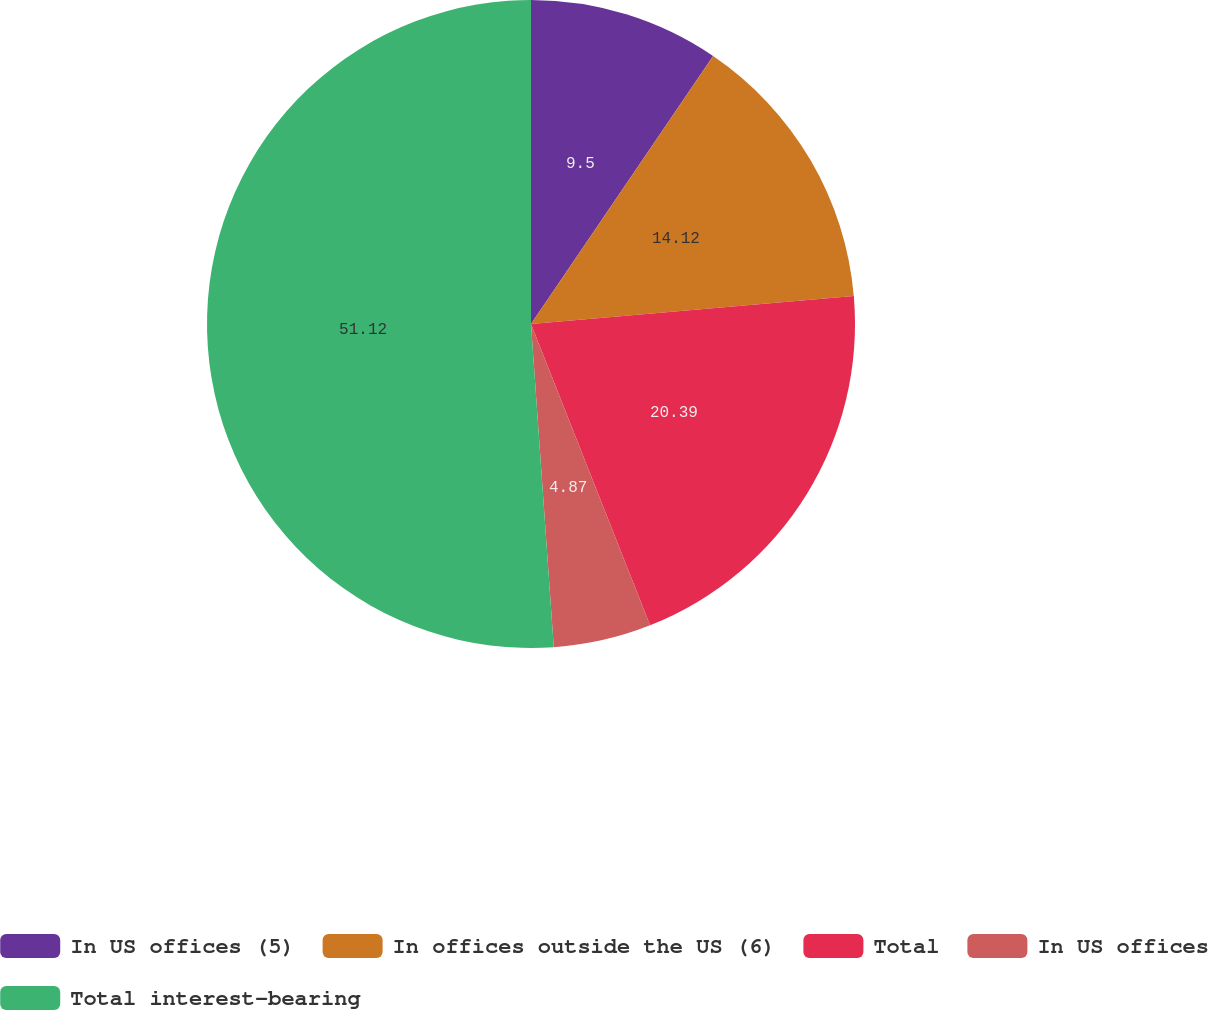<chart> <loc_0><loc_0><loc_500><loc_500><pie_chart><fcel>In US offices (5)<fcel>In offices outside the US (6)<fcel>Total<fcel>In US offices<fcel>Total interest-bearing<nl><fcel>9.5%<fcel>14.12%<fcel>20.39%<fcel>4.87%<fcel>51.12%<nl></chart> 